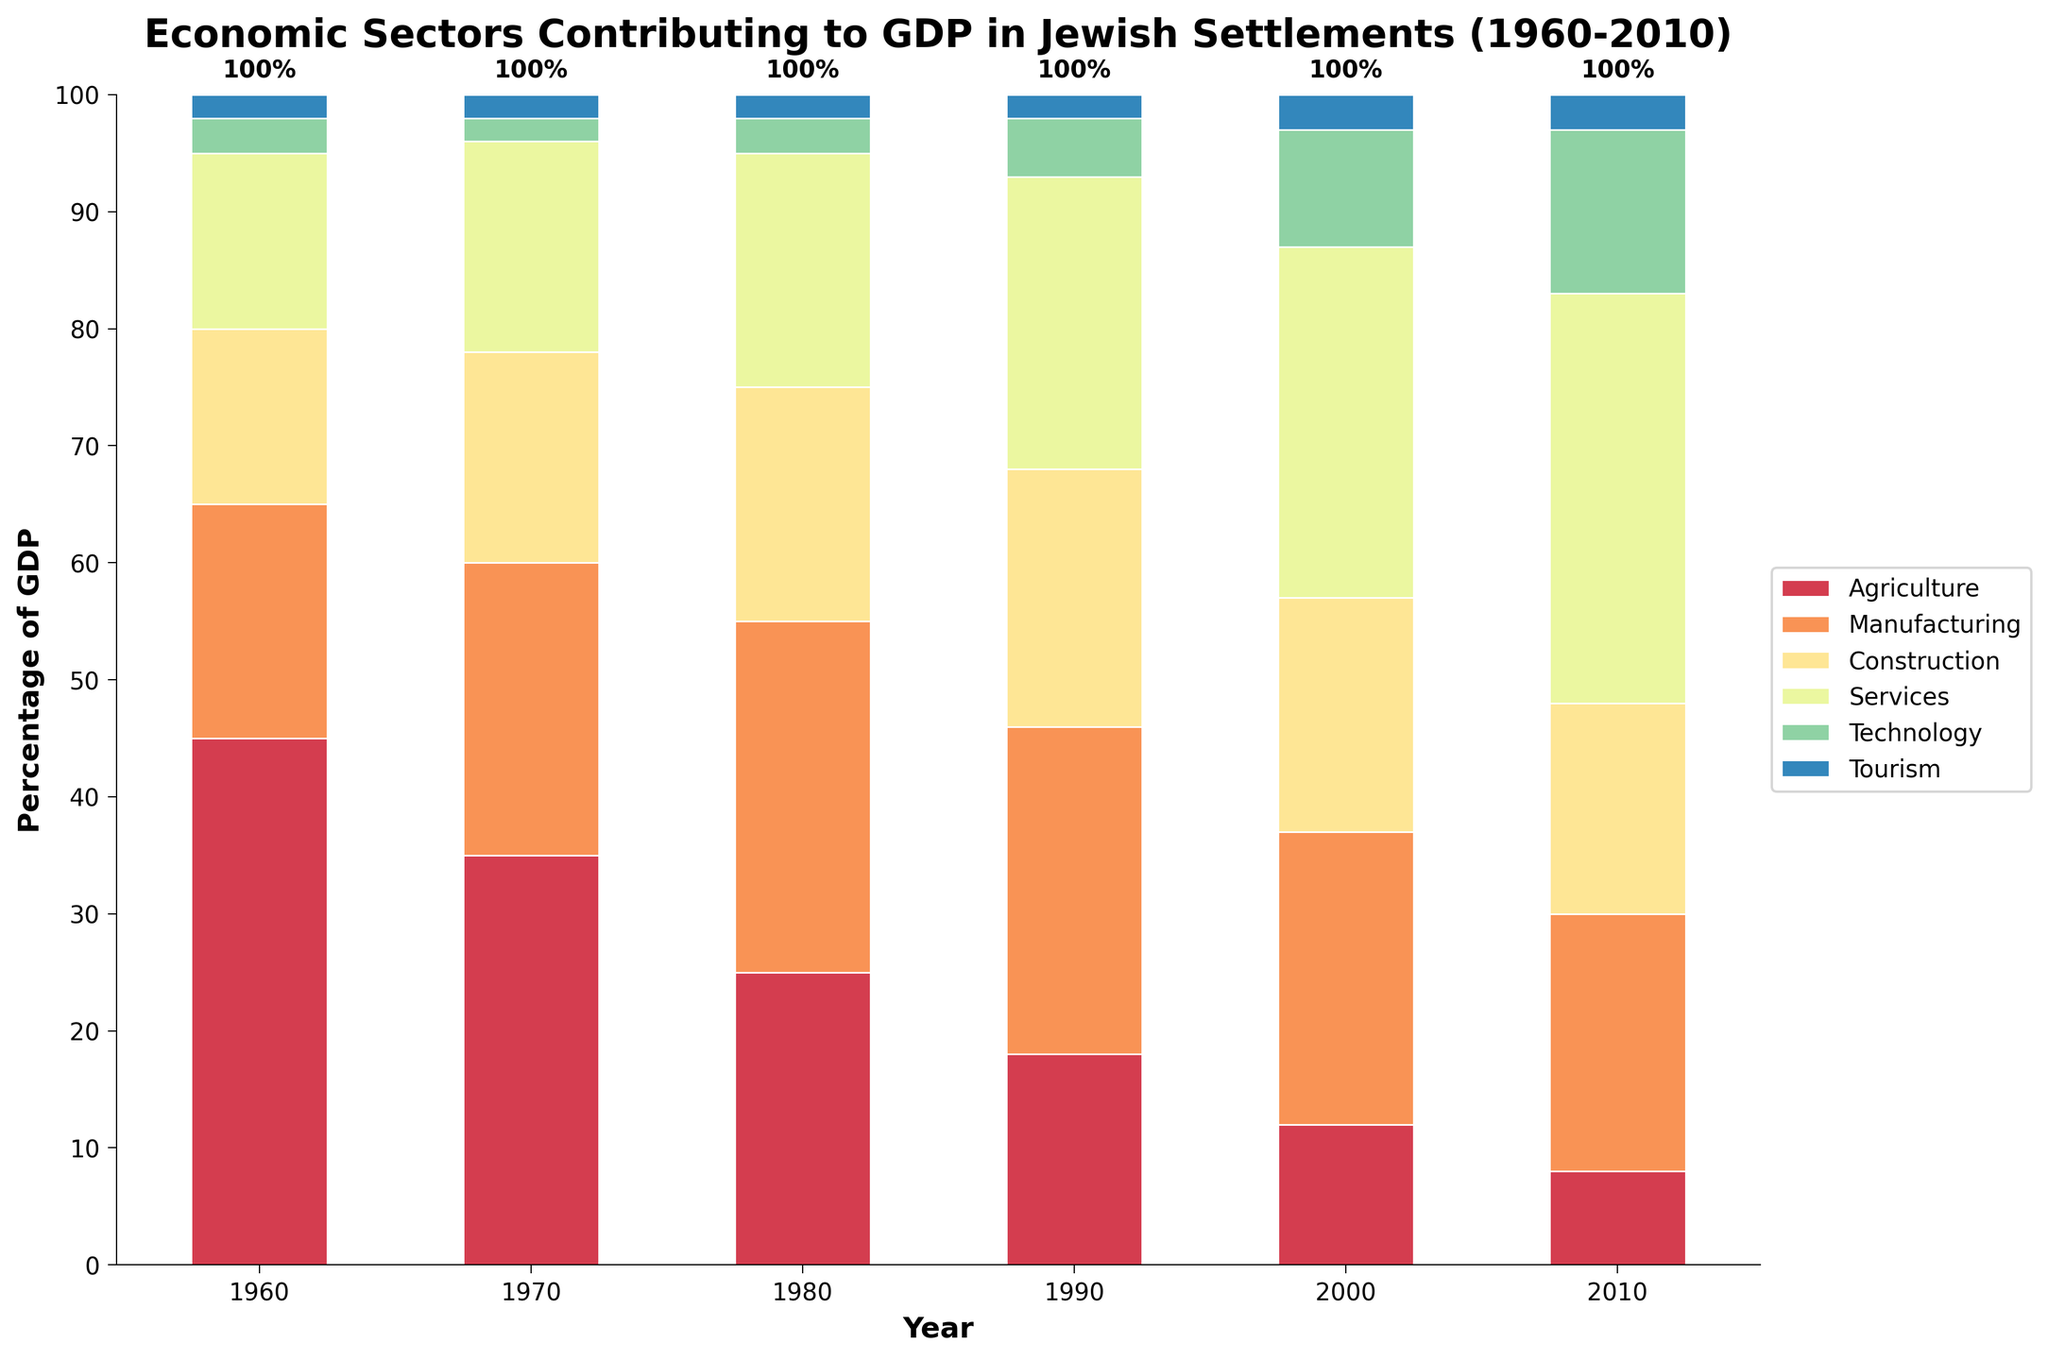What sector had the highest contribution to GDP in 1960? In the 1960 bar, Agriculture appears the tallest among all sectors, indicating it had the highest contribution to GDP.
Answer: Agriculture How did the contribution of the Technology sector change from 1960 to 2010? In 1960, the Technology sector is nearly invisible. By 2010, its contribution has grown substantially, rising to a visible segment among the sectors.
Answer: Increased In which year did Services overtake Agriculture in terms of GDP contribution? Comparing the bars, Services surpassed Agriculture in 1990. In 1990, the Services bar is taller than the Agriculture bar for the first time.
Answer: 1990 By how much did the contribution of Manufacturing change between 1960 and 2010? The height of the Manufacturing bar in 1960 is 20%, and in 2010 it is 22%. The difference is calculated as 22% - 20% = 2%.
Answer: 2% Which sector had the most consistent contribution to the GDP throughout 1960-2010? The Tourism sector shows very little change over the years, remaining consistently around 2-3%. Other sectors exhibit more significant fluctuations over the decades.
Answer: Tourism What is the sum of the GDP contributions of Agriculture and Technology in 2010? In 2010, Agriculture contributed 8% and Technology contributed 14%. The sum is calculated as 8% + 14% = 22%.
Answer: 22% In 1980, was the contribution from Construction more than that from Tourism and Technology combined? In 1980, Construction is 20%, whereas Tourism and Technology combined is 2% (Tourism) + 3% (Technology) = 5%. Therefore, Construction contributed more.
Answer: Yes How much did the contribution of the Agriculture sector decrease from 1960 to 2000? Agriculture in 1960 was 45%, and in 2000 it was 12%. The decrease is 45% - 12% = 33%.
Answer: 33% Which sectors’ contributions remained unchanged between 1960 and 1970? By comparing the heights of each sector's bar between 1960 and 1970, both Tourism and Technology remained at 2% in both years.
Answer: Tourism and Technology What is the total GDP contribution from the Services sector over all the shown years? Summing up the contributions: 1960: 15%, 1970: 18%, 1980: 20%, 1990: 25%, 2000: 30%, 2010: 35%. The total is 15 + 18 + 20 + 25 + 30 + 35 = 143%.
Answer: 143% 